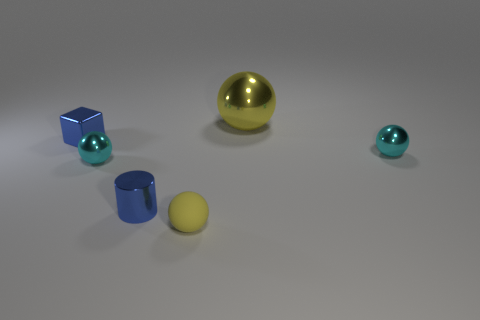Subtract 1 balls. How many balls are left? 3 Add 3 green rubber balls. How many objects exist? 9 Subtract all cubes. How many objects are left? 5 Subtract 0 cyan blocks. How many objects are left? 6 Subtract all yellow metal spheres. Subtract all tiny cyan matte cubes. How many objects are left? 5 Add 2 tiny blocks. How many tiny blocks are left? 3 Add 2 blue cylinders. How many blue cylinders exist? 3 